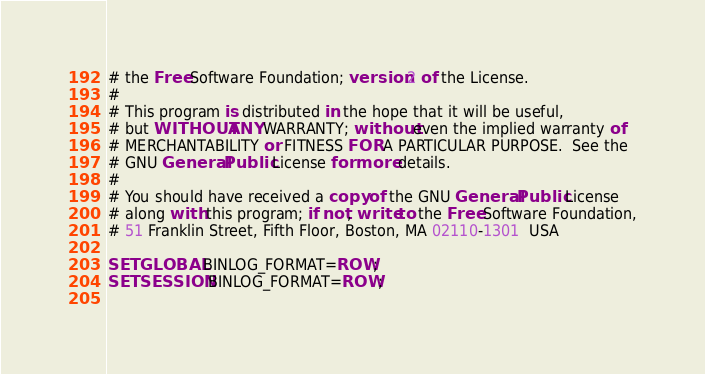Convert code to text. <code><loc_0><loc_0><loc_500><loc_500><_SQL_># the Free Software Foundation; version 2 of the License.
#
# This program is distributed in the hope that it will be useful,
# but WITHOUT ANY WARRANTY; without even the implied warranty of
# MERCHANTABILITY or FITNESS FOR A PARTICULAR PURPOSE.  See the
# GNU General Public License for more details.
#
# You should have received a copy of the GNU General Public License
# along with this program; if not, write to the Free Software Foundation,
# 51 Franklin Street, Fifth Floor, Boston, MA 02110-1301  USA

SET GLOBAL BINLOG_FORMAT=ROW;
SET SESSION BINLOG_FORMAT=ROW;
 </code> 